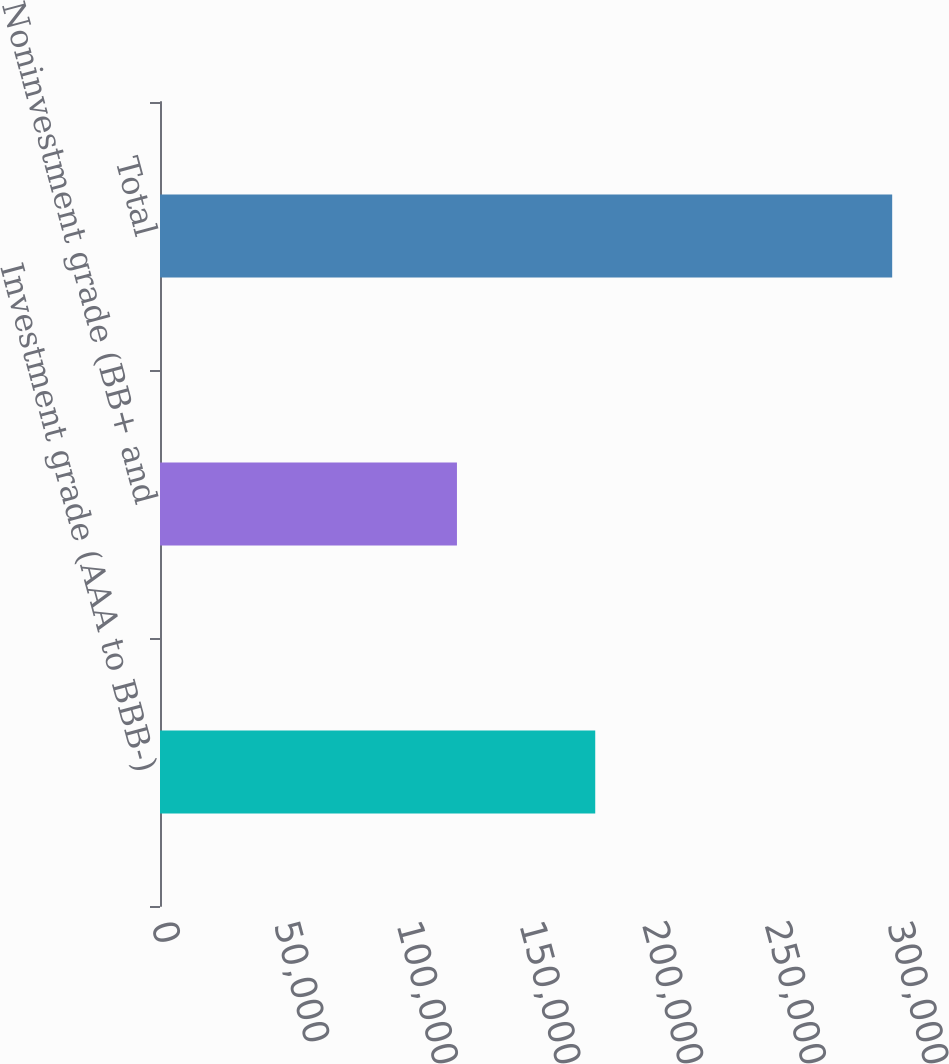<chart> <loc_0><loc_0><loc_500><loc_500><bar_chart><fcel>Investment grade (AAA to BBB-)<fcel>Noninvestment grade (BB+ and<fcel>Total<nl><fcel>177404<fcel>121040<fcel>298444<nl></chart> 